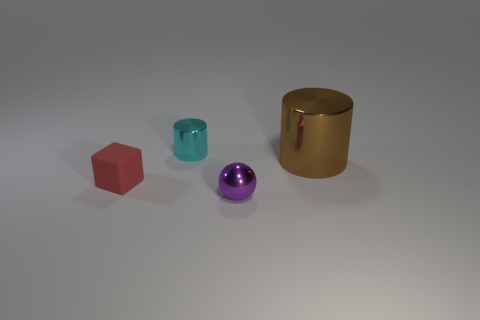Add 3 small purple shiny objects. How many objects exist? 7 Subtract all blocks. How many objects are left? 3 Add 3 tiny matte objects. How many tiny matte objects are left? 4 Add 4 tiny rubber objects. How many tiny rubber objects exist? 5 Subtract 1 cyan cylinders. How many objects are left? 3 Subtract all cyan cylinders. Subtract all yellow balls. How many cylinders are left? 1 Subtract all small yellow cubes. Subtract all cubes. How many objects are left? 3 